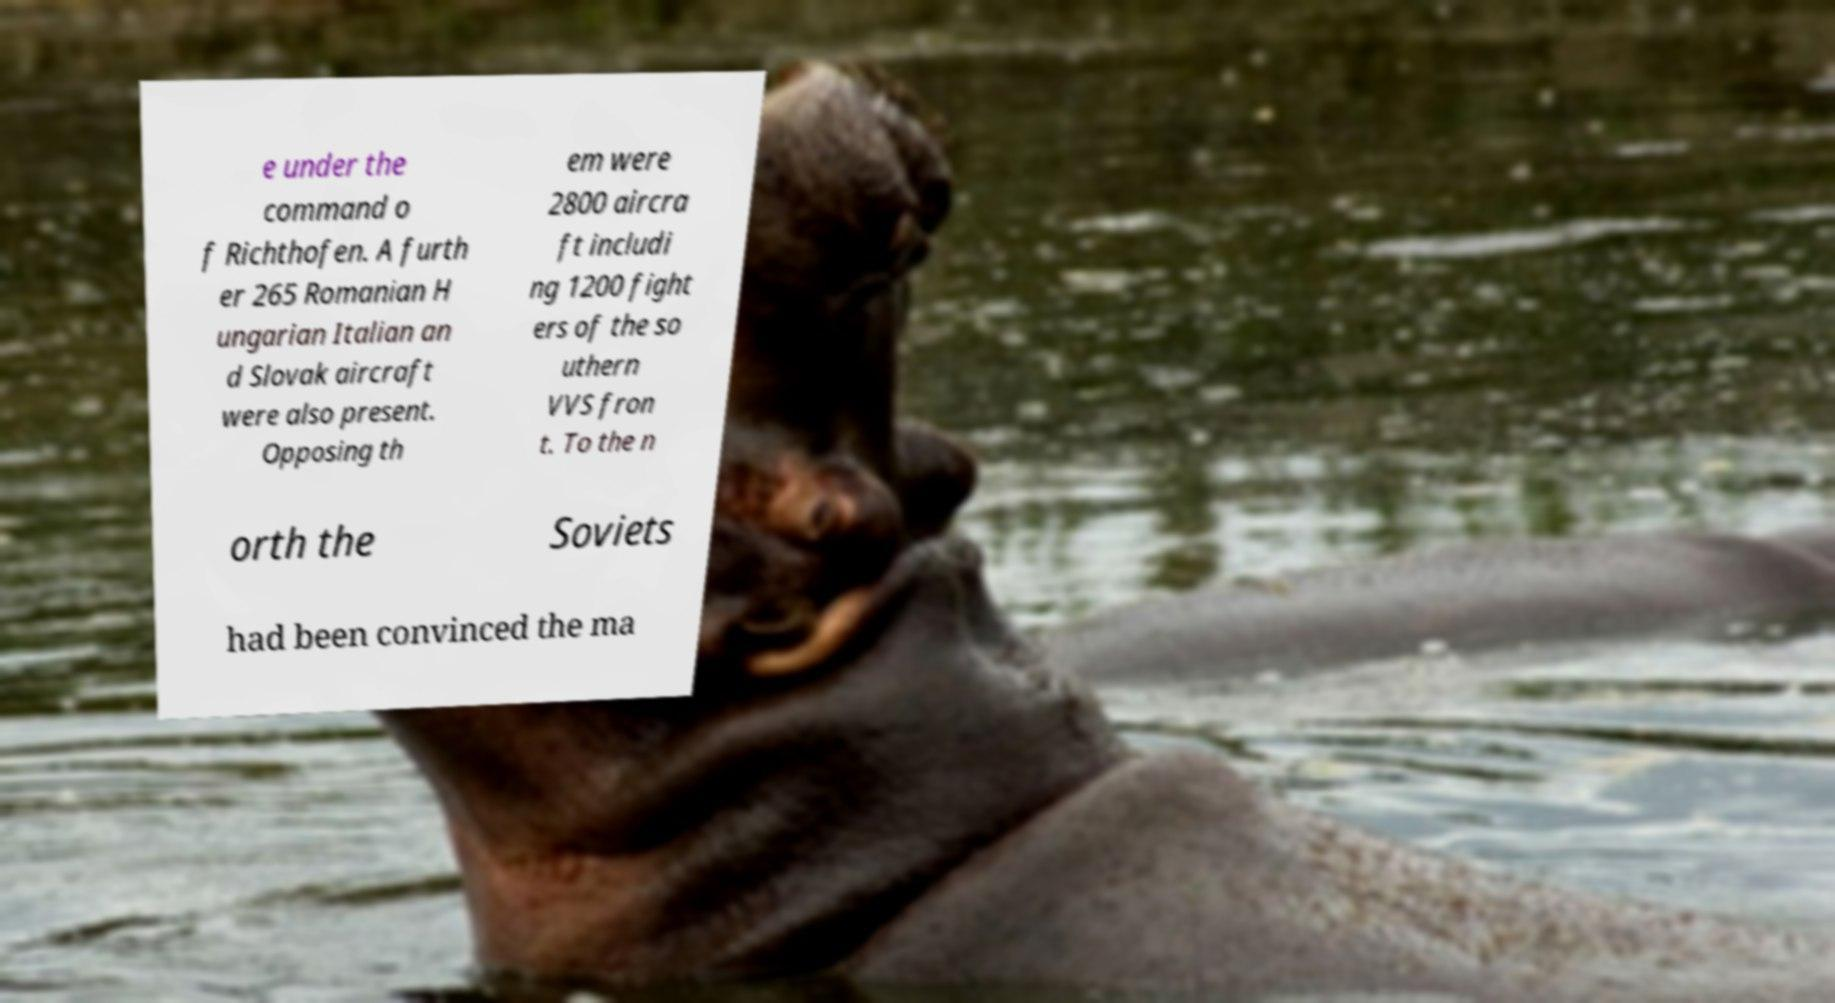Could you assist in decoding the text presented in this image and type it out clearly? e under the command o f Richthofen. A furth er 265 Romanian H ungarian Italian an d Slovak aircraft were also present. Opposing th em were 2800 aircra ft includi ng 1200 fight ers of the so uthern VVS fron t. To the n orth the Soviets had been convinced the ma 